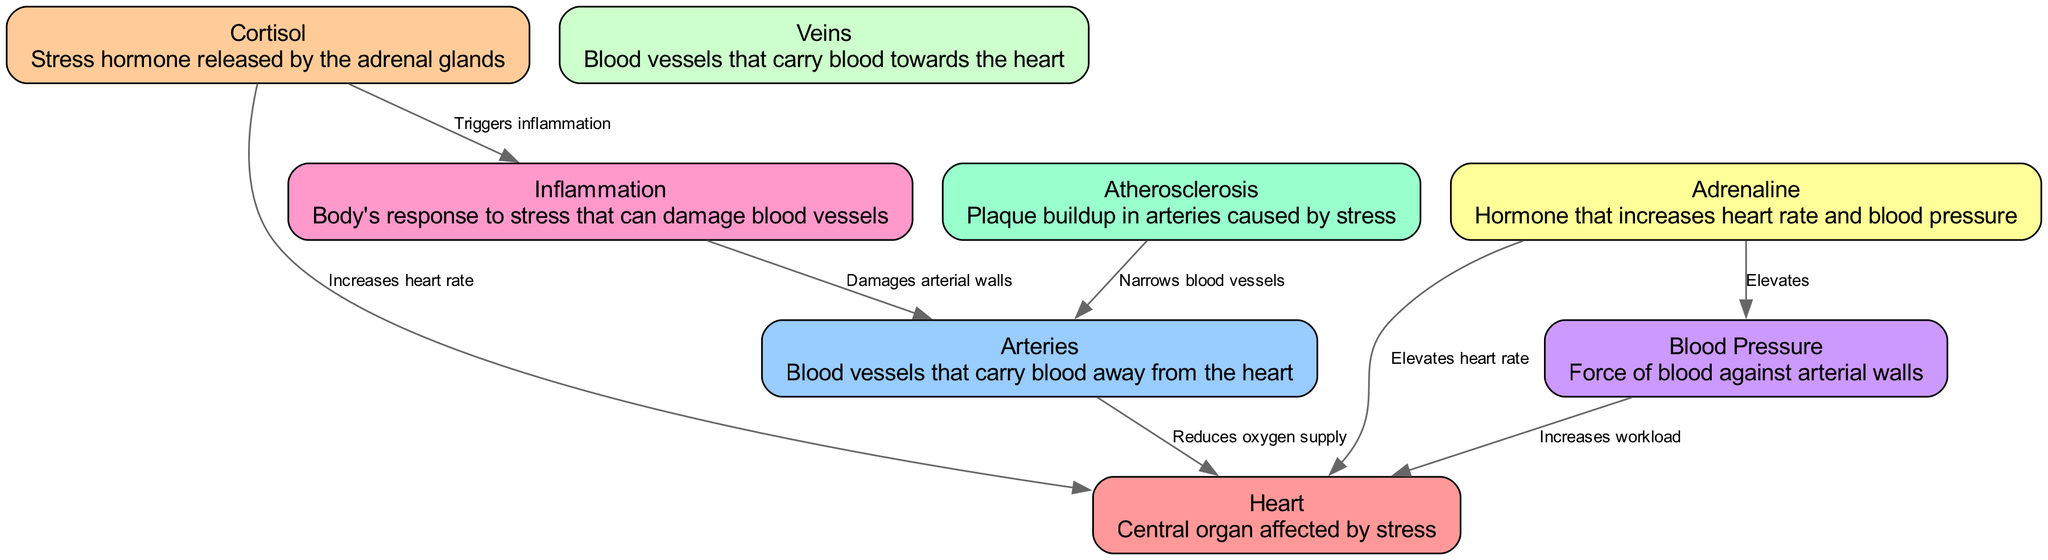What are the main hormonal responses depicted in the diagram? The diagram shows "Cortisol" and "Adrenaline" as the primary hormones affecting cardiovascular health.
Answer: Cortisol, Adrenaline How many nodes are there in the diagram? By counting the nodes listed in the data, we find a total of 8 distinct nodes including heart, arteries, veins, cortisol, adrenaline, inflammation, blood pressure, and atherosclerosis.
Answer: 8 What is the relationship between cortisol and heart rate? The diagram indicates that cortisol "Increases heart rate," linking its release directly to the central organ's functionality during stress.
Answer: Increases heart rate Which blood vessels are most affected by inflammation according to the diagram? According to the diagram, inflammation damages the "arterial walls," showing a direct connection between stress responses and blood vessel health.
Answer: Arteries What impact does adrenaline have on blood pressure? The diagram states that adrenaline "Elevates" blood pressure, indicating its role in increasing cardiovascular stress.
Answer: Elevates How does stress-induced inflammation affect arteries? The diagram illustrates that inflammation damages arterial walls, signifying that this physiological response has detrimental effects on vascular health.
Answer: Damages arterial walls What happens to oxygen supply to the heart when arteries are narrowed? The diagram depicts that when arteries are affected by atherosclerosis, they "Reduces oxygen supply" to the heart, highlighting the physiological consequences of stress.
Answer: Reduces oxygen supply What type of plaque buildup is associated with stress as depicted? The diagram links atherosclerosis to stress, indicating it's a type of plaque buildup that occurs in arteries.
Answer: Atherosclerosis 